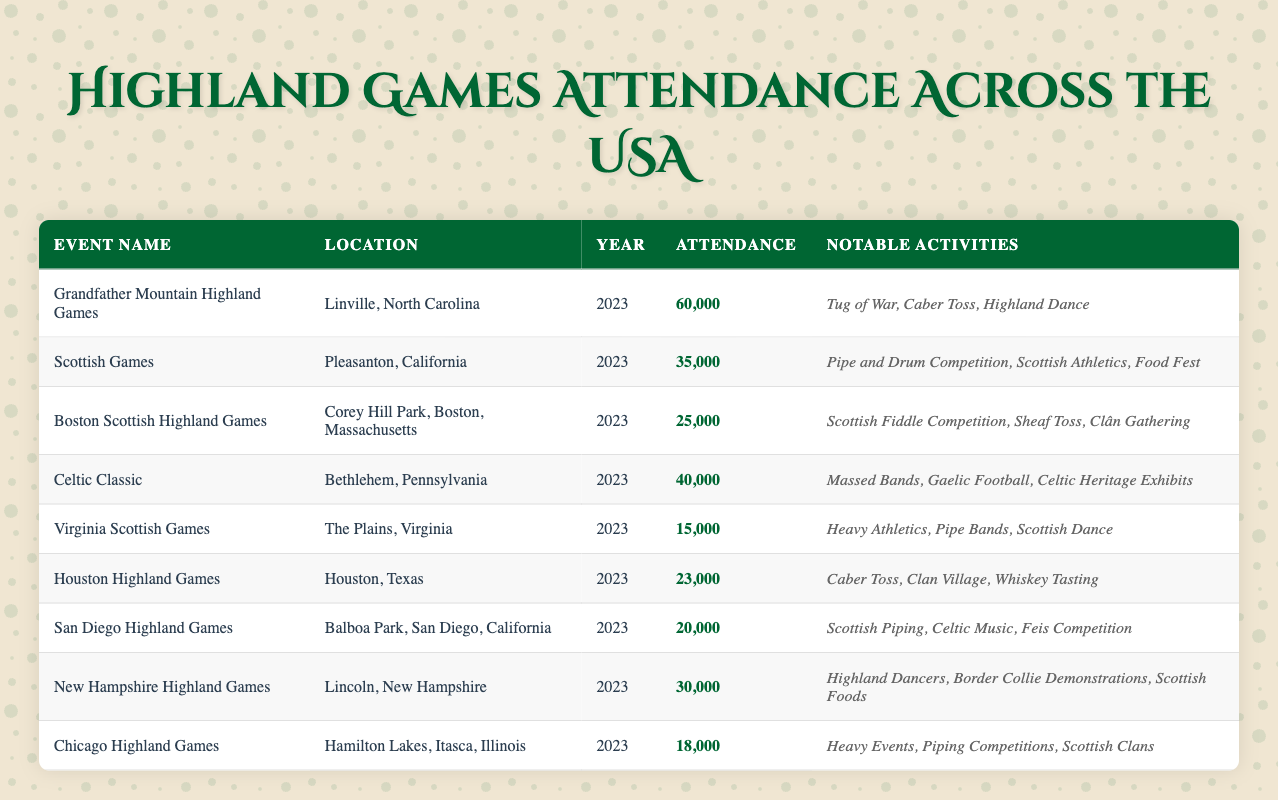What is the highest attendance recorded at the Highland Games in 2023? The table lists several events along with their attendance. The highest attendance is 60,000 for the Grandfather Mountain Highland Games in Linville, North Carolina.
Answer: 60,000 Which event had the lowest attendance? The table indicates that the Virginia Scottish Games had the lowest attendance with 15,000.
Answer: 15,000 How many events recorded an attendance of over 30,000? By analyzing each event's attendance from the table, there are four events (Grandfather Mountain, Scottish Games, Celtic Classic, and New Hampshire) that had attendance over 30,000.
Answer: 4 What is the total attendance of all the events listed? Summing the attendance values from the table: 60,000 + 35,000 + 25,000 + 40,000 + 15,000 + 23,000 + 20,000 + 30,000 + 18,000 = 276,000 total attendance across events.
Answer: 276,000 Is there an event in Massachusetts? The Boston Scottish Highland Games is located in Corey Hill Park, Boston, Massachusetts, confirming the presence of an event in that state.
Answer: Yes What is the average attendance of the Highland Games in California? The Scottish Games and San Diego Highland Games are both in California, with attendance of 35,000 and 20,000 respectively. The average is (35,000 + 20,000) / 2 = 27,500.
Answer: 27,500 Which event had more notable activities: Grandfather Mountain Highland Games or Celtic Classic? The Grandfather Mountain Highland Games has 3 notable activities (Tug of War, Caber Toss, Highland Dance), while Celtic Classic also has 3 notable activities (Massed Bands, Gaelic Football, Celtic Heritage Exhibits). Both have the same number of activities.
Answer: Equal If you consider Chicago, Massachusetts, and Virginia, which state had the highest attendance? Chicago is in Illinois with 18,000, Massachusetts has Boston with 25,000, and Virginia has the lowest with 15,000. Comparing these, Massachusetts has the highest attendance of 25,000.
Answer: Massachusetts Are there more events in northern or southern states based on the provided data? The data shows events in North Carolina, Massachusetts, Pennsylvania, Virginia (northern), and Texas, California, New Hampshire, and Illinois (southern). Count shows 4 in northern and 5 in southern.
Answer: Southern What activities are featured in the Houston Highland Games? The notable activities at the Houston Highland Games include Caber Toss, Clan Village, and Whiskey Tasting.
Answer: Caber Toss, Clan Village, Whiskey Tasting 